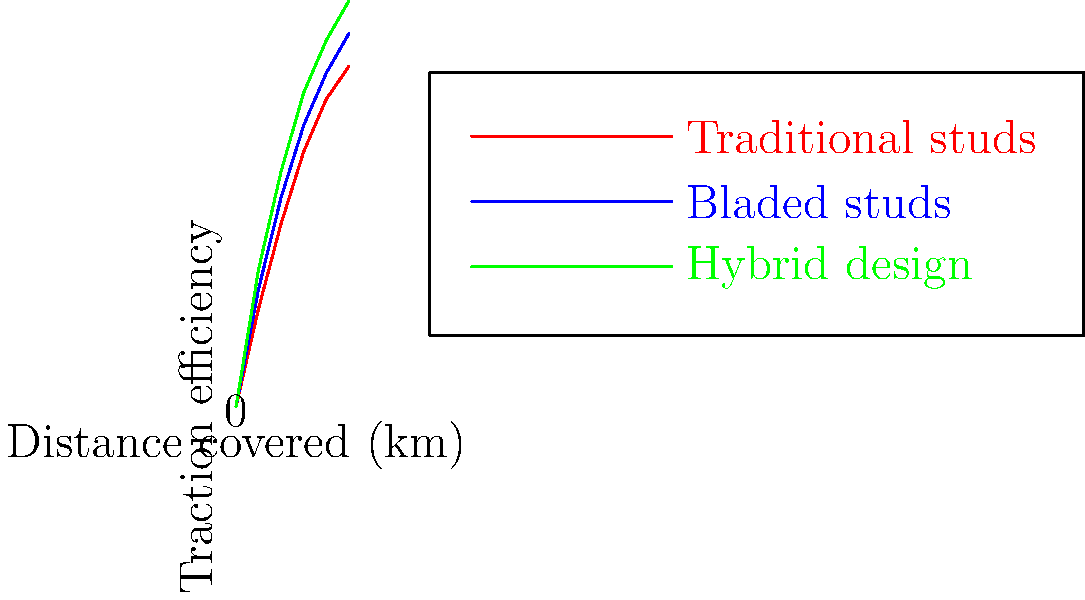Based on the graph comparing the traction efficiency of different football cleat designs over distance covered, which design shows the highest overall efficiency, and how might this impact a player's performance during a match? To answer this question, we need to analyze the graph and consider the implications for football players:

1. The graph shows three different cleat designs: traditional studs (red), bladed studs (blue), and a hybrid design (green).

2. The x-axis represents the distance covered in kilometers, while the y-axis shows the traction efficiency.

3. Comparing the three lines:
   - The hybrid design (green) consistently shows the highest traction efficiency across all distances.
   - The bladed studs (blue) are second in efficiency.
   - The traditional studs (red) show the lowest efficiency.

4. The hybrid design's superior performance can be attributed to its combination of traditional and bladed stud features, optimizing traction on various surfaces and conditions.

5. Impact on player performance:
   - Higher traction efficiency allows for better grip and stability on the field.
   - This can lead to improved acceleration, quicker changes in direction, and more precise movements.
   - Players using the hybrid design may experience less slipping and better energy transfer when running or making sharp turns.
   - Over the course of a match, this improved efficiency could result in reduced fatigue and potentially better overall performance.

6. It's important to note that while the hybrid design shows the best overall efficiency, individual player preferences and specific field conditions may still influence the choice of cleats.
Answer: Hybrid design; improved grip, stability, and movement efficiency throughout the match. 